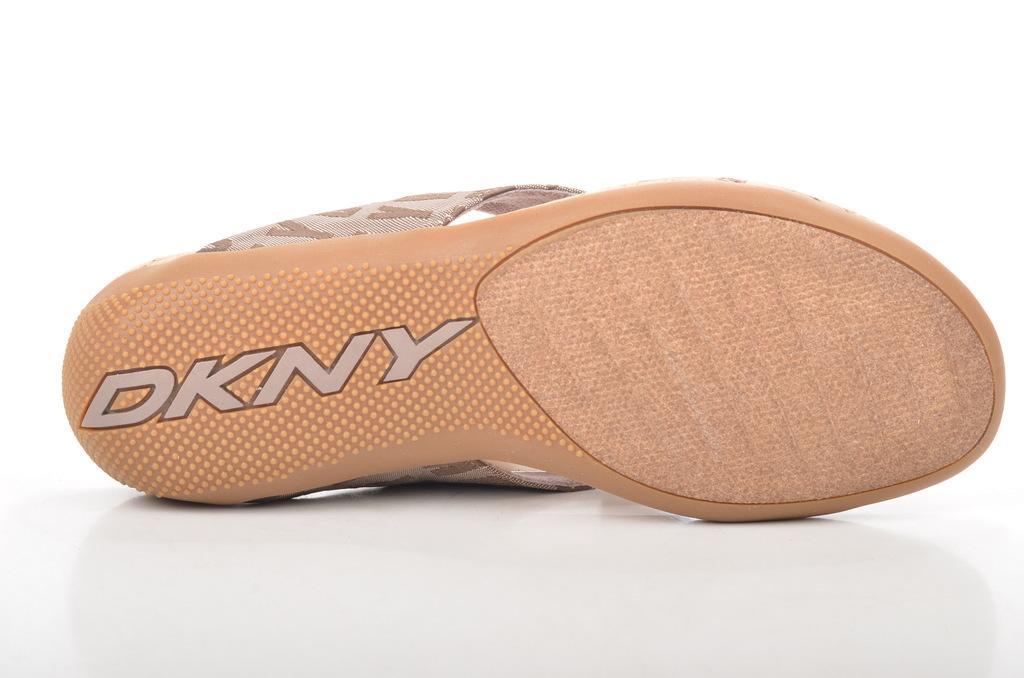Describe this image in one or two sentences. In the picture we can see footwear which is cream in color and name on it DKNY. 